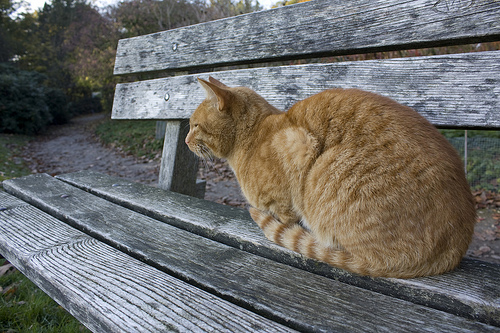How is the weather? The weather is sunny, providing a clear and bright atmosphere. 